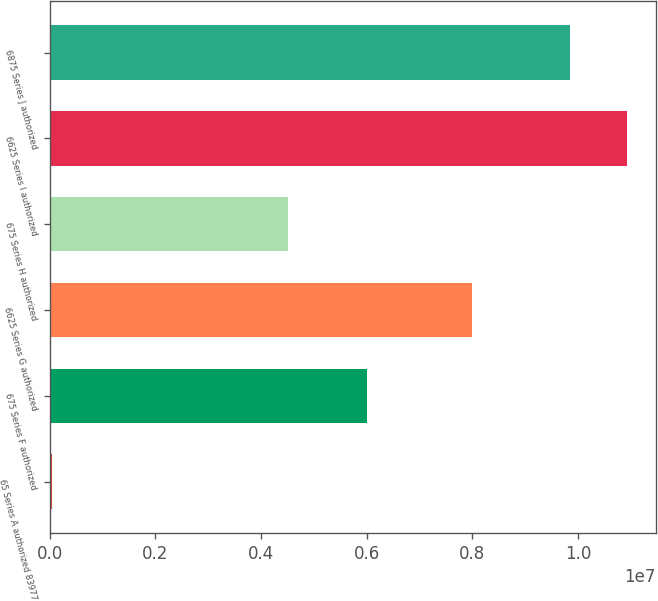Convert chart to OTSL. <chart><loc_0><loc_0><loc_500><loc_500><bar_chart><fcel>65 Series A authorized 83977<fcel>675 Series F authorized<fcel>6625 Series G authorized<fcel>675 Series H authorized<fcel>6625 Series I authorized<fcel>6875 Series J authorized<nl><fcel>36709<fcel>6e+06<fcel>8e+06<fcel>4.5e+06<fcel>1.09263e+07<fcel>9.85e+06<nl></chart> 